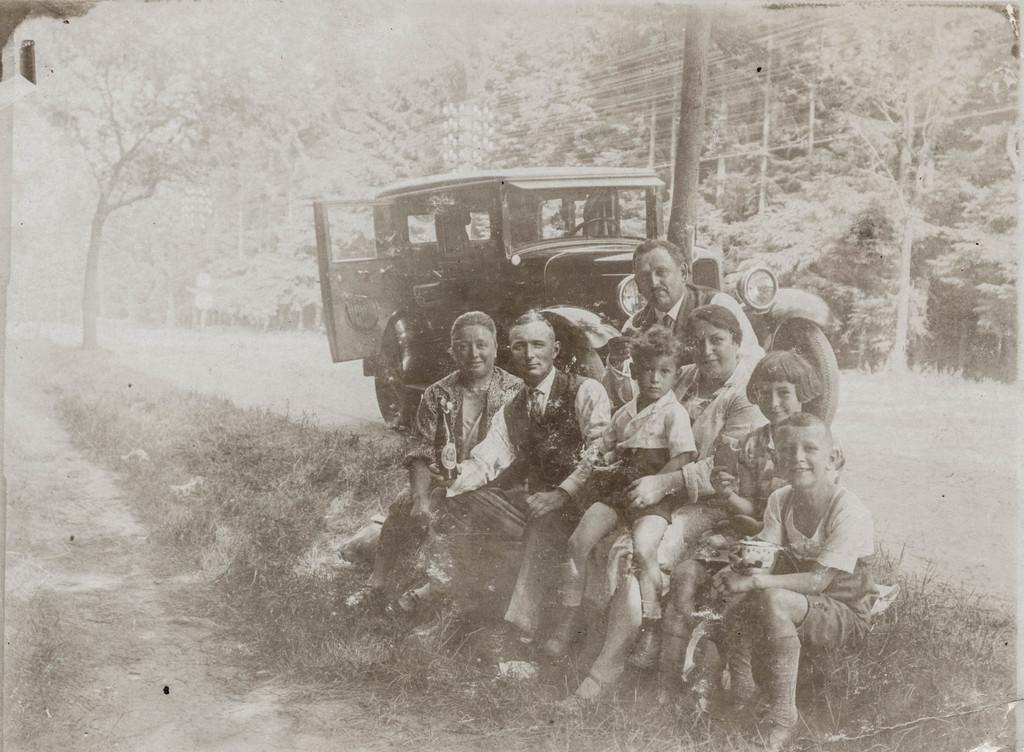What are the people in the image doing? There is a group of people sitting in the image. What is the person in front holding? The person in front is holding a glass. What can be seen in the background of the image? There is a vehicle in the background of the image. What is the color scheme of the image? The image is in black and white. Can you see any jails or matches in the image? No, there are no jails or matches present in the image. Is there an ocean visible in the image? No, there is no ocean visible in the image. 